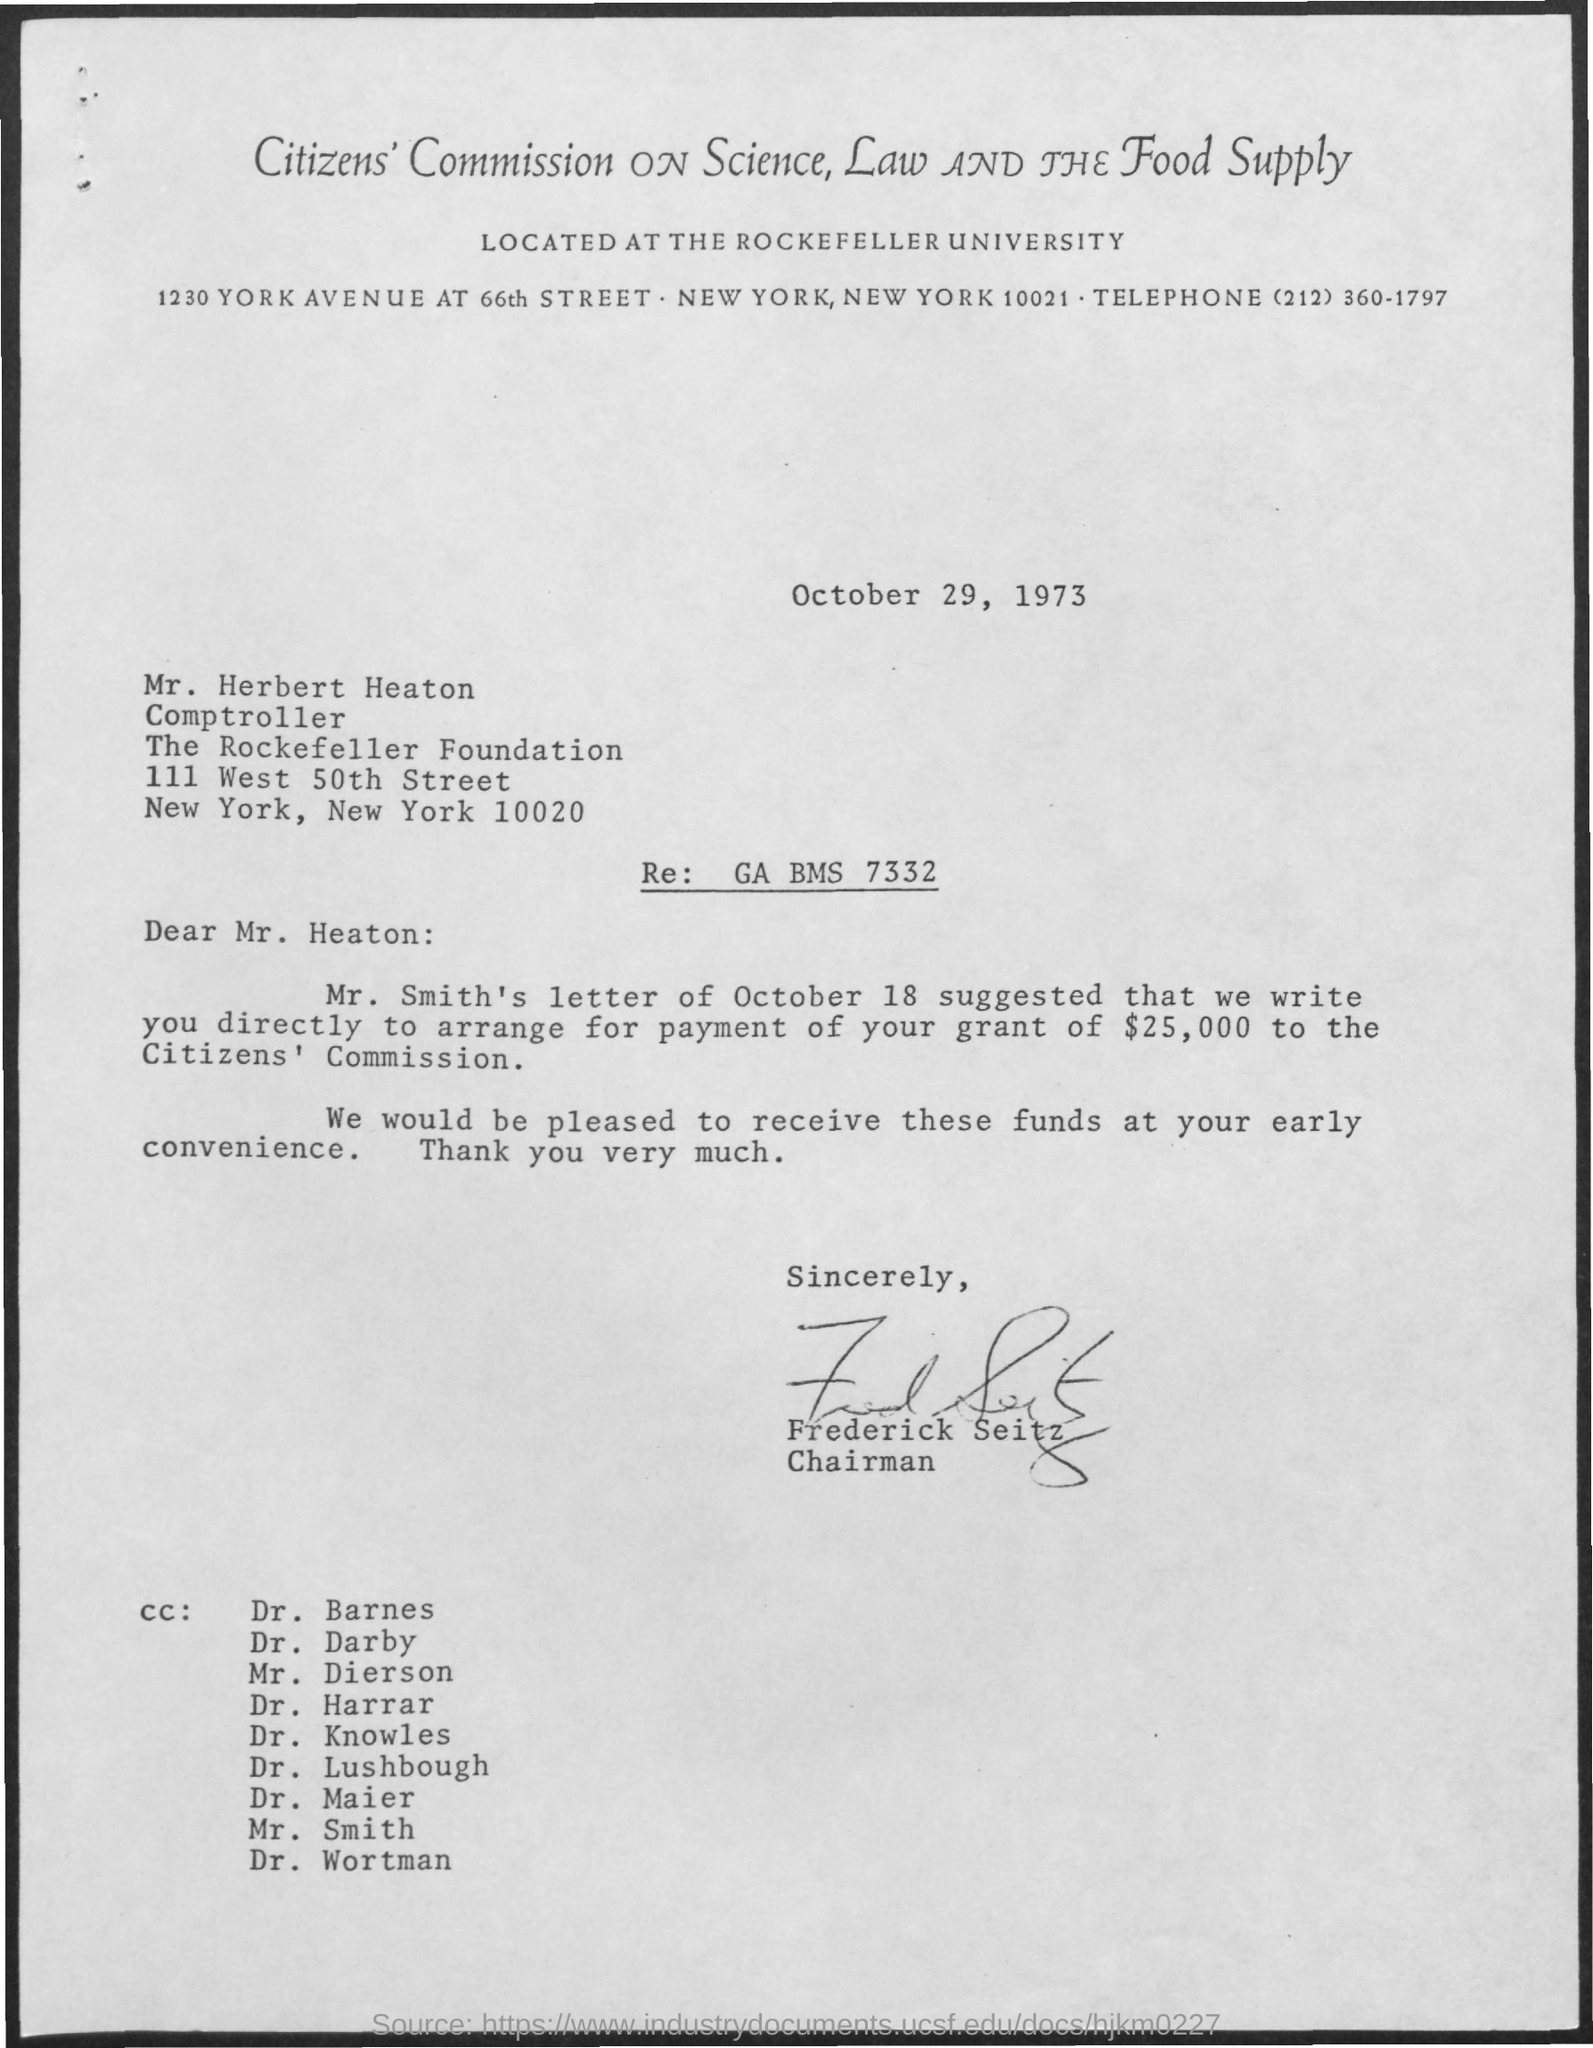Point out several critical features in this image. The date mentioned in the given letter is October 29, 1973. The subject of the email is "Who's sign was there at the end of the mail? FREDERICK SEITZ..". 